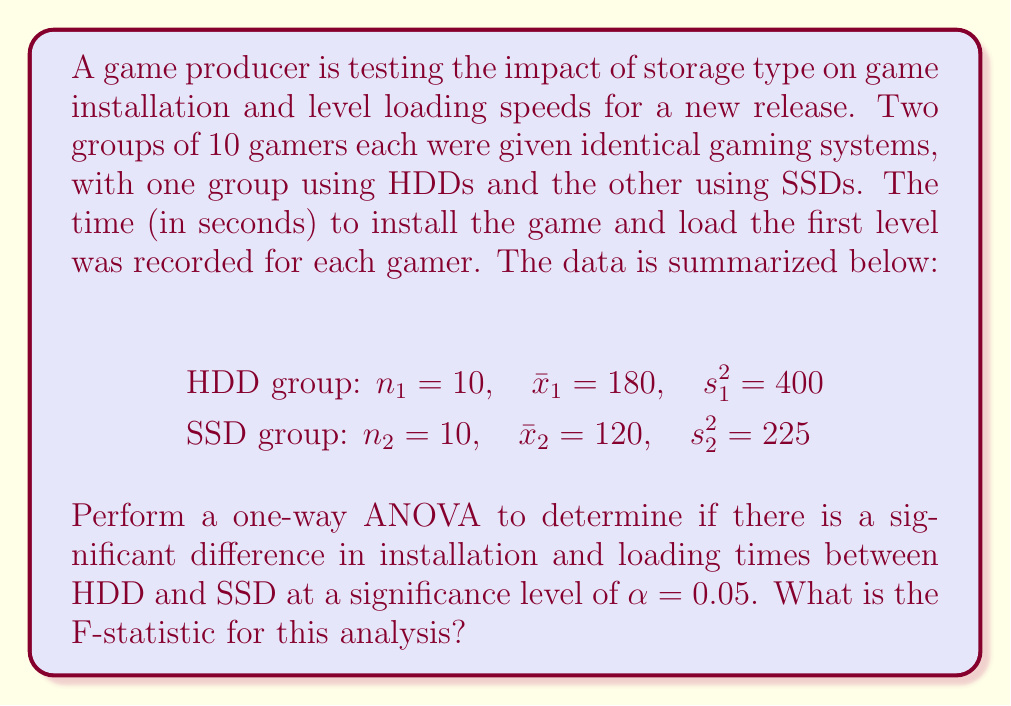Teach me how to tackle this problem. To perform a one-way ANOVA, we need to calculate the F-statistic. The steps are as follows:

1. Calculate the between-group sum of squares (SSB):
   $$SSB = n_1(\bar{x}_1 - \bar{x})^2 + n_2(\bar{x}_2 - \bar{x})^2$$
   where $\bar{x}$ is the grand mean.

2. Calculate the within-group sum of squares (SSW):
   $$SSW = (n_1 - 1)s_1^2 + (n_2 - 1)s_2^2$$

3. Calculate the total sum of squares (SST):
   $$SST = SSB + SSW$$

4. Calculate the degrees of freedom:
   $df_{between} = k - 1$ (where $k$ is the number of groups)
   $df_{within} = N - k$ (where $N$ is the total number of observations)

5. Calculate the mean square between (MSB) and mean square within (MSW):
   $$MSB = \frac{SSB}{df_{between}}$$
   $$MSW = \frac{SSW}{df_{within}}$$

6. Calculate the F-statistic:
   $$F = \frac{MSB}{MSW}$$

Let's proceed with the calculations:

First, calculate the grand mean:
$$\bar{x} = \frac{n_1\bar{x}_1 + n_2\bar{x}_2}{n_1 + n_2} = \frac{10(180) + 10(120)}{20} = 150$$

Now, calculate SSB:
$$SSB = 10(180 - 150)^2 + 10(120 - 150)^2 = 10(900) + 10(900) = 18000$$

Calculate SSW:
$$SSW = (10 - 1)400 + (10 - 1)225 = 3600 + 2025 = 5625$$

Calculate SST:
$$SST = SSB + SSW = 18000 + 5625 = 23625$$

Degrees of freedom:
$df_{between} = 2 - 1 = 1$
$df_{within} = 20 - 2 = 18$

Calculate MSB and MSW:
$$MSB = \frac{SSB}{df_{between}} = \frac{18000}{1} = 18000$$
$$MSW = \frac{SSW}{df_{within}} = \frac{5625}{18} = 312.5$$

Finally, calculate the F-statistic:
$$F = \frac{MSB}{MSW} = \frac{18000}{312.5} = 57.6$$
Answer: The F-statistic for this analysis is 57.6. 